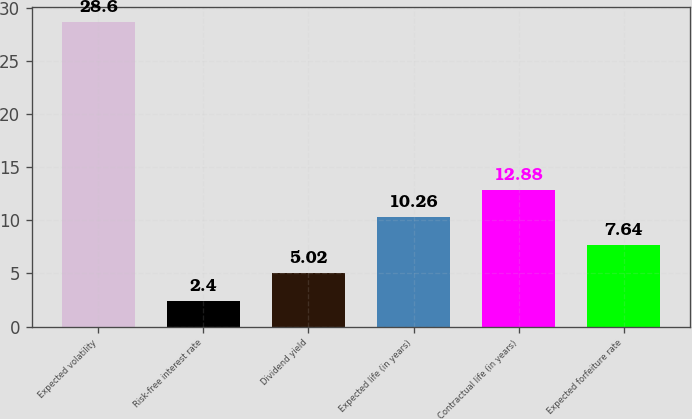Convert chart. <chart><loc_0><loc_0><loc_500><loc_500><bar_chart><fcel>Expected volatility<fcel>Risk-free interest rate<fcel>Dividend yield<fcel>Expected life (in years)<fcel>Contractual life (in years)<fcel>Expected forfeiture rate<nl><fcel>28.6<fcel>2.4<fcel>5.02<fcel>10.26<fcel>12.88<fcel>7.64<nl></chart> 